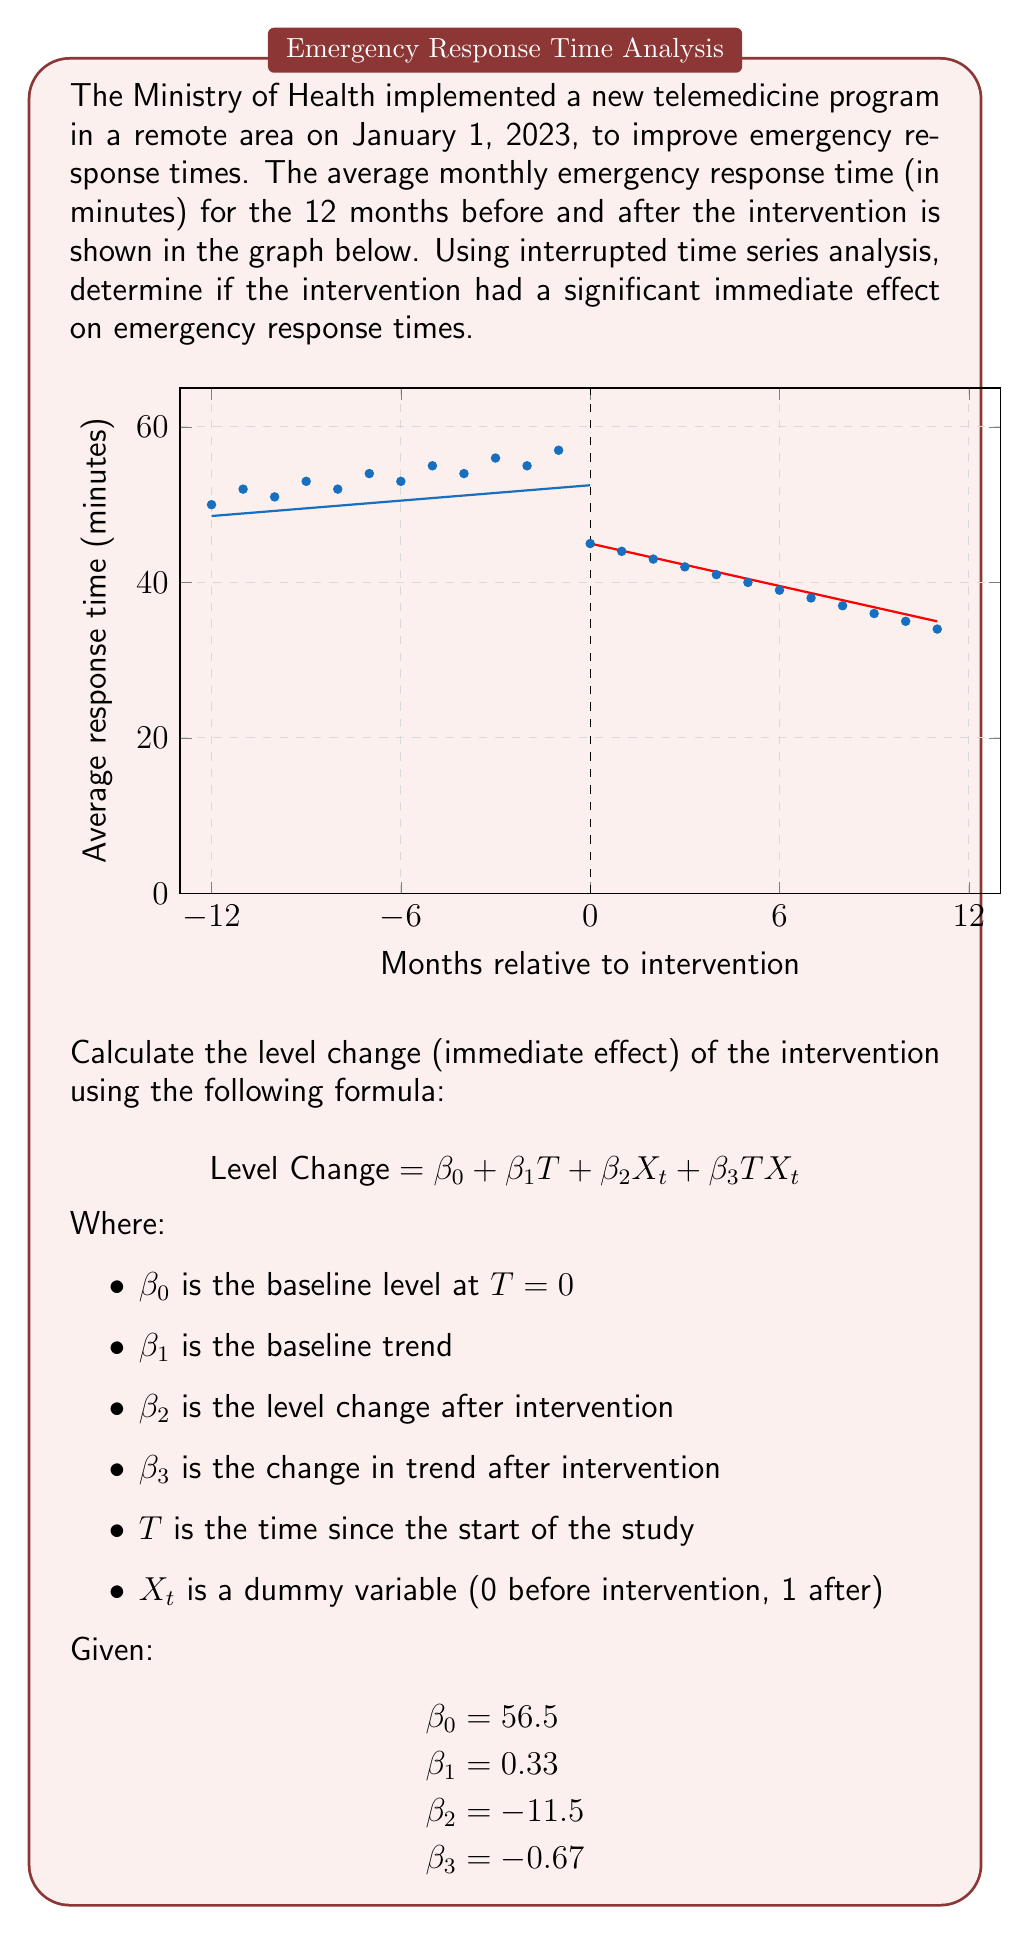What is the answer to this math problem? To calculate the level change (immediate effect) of the intervention, we need to use the interrupted time series model equation:

$$ \text{Level Change} = \beta_0 + \beta_1T + \beta_2X_t + \beta_3TX_t $$

We're interested in the immediate effect, which occurs at the moment of intervention ($T=0$). At this point:

1. $T = 0$ (time of intervention)
2. $X_t = 1$ (dummy variable is 1 after intervention)

Let's substitute these values and the given coefficients into the equation:

$$ \text{Level Change} = \beta_0 + \beta_1(0) + \beta_2(1) + \beta_3(0)(1) $$

$$ \text{Level Change} = 56.5 + 0 + (-11.5) + 0 $$

$$ \text{Level Change} = 56.5 - 11.5 $$

$$ \text{Level Change} = 45 $$

The level change of -11.5 minutes represents a significant immediate decrease in emergency response times following the intervention. This suggests that the telemedicine program had a positive immediate effect on reducing response times in the remote area.
Answer: -11.5 minutes 